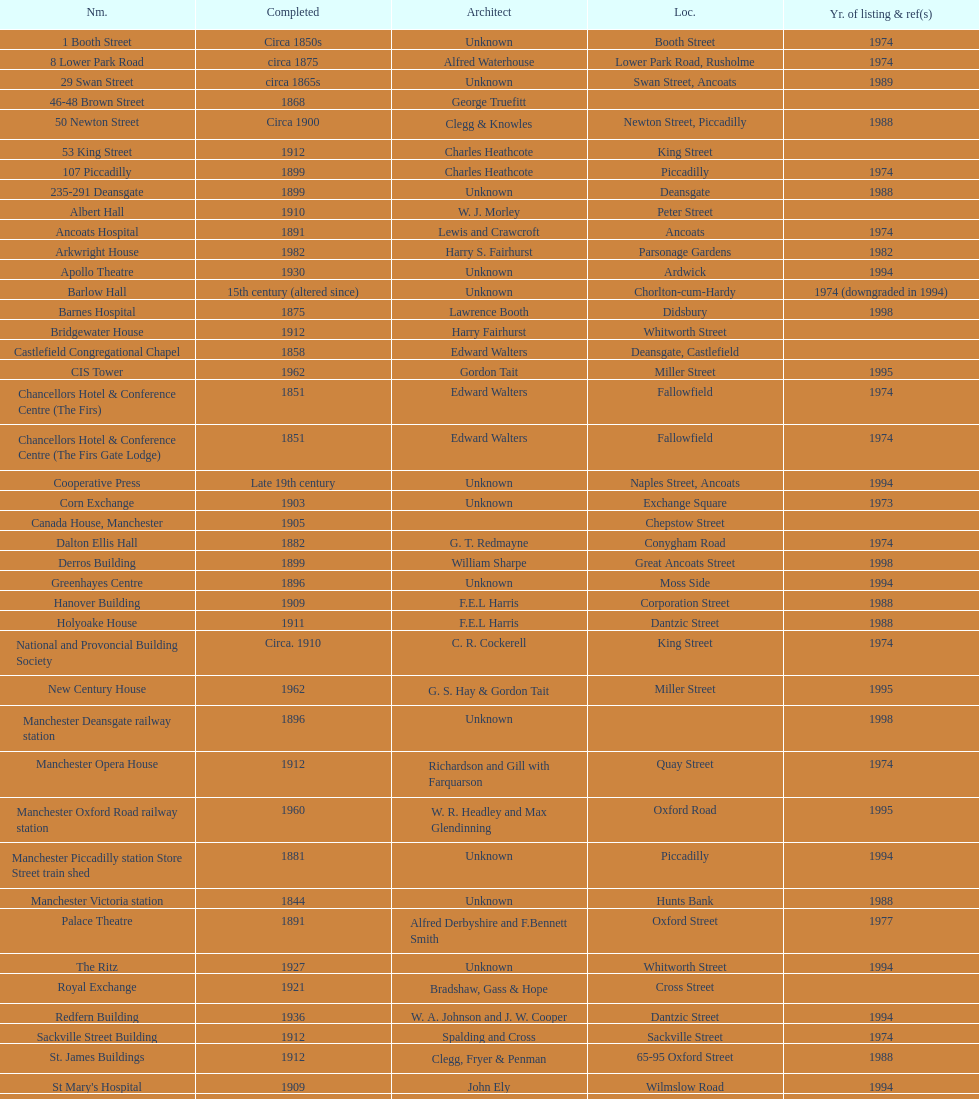What is the difference, in years, between the completion dates of 53 king street and castlefield congregational chapel? 54 years. 